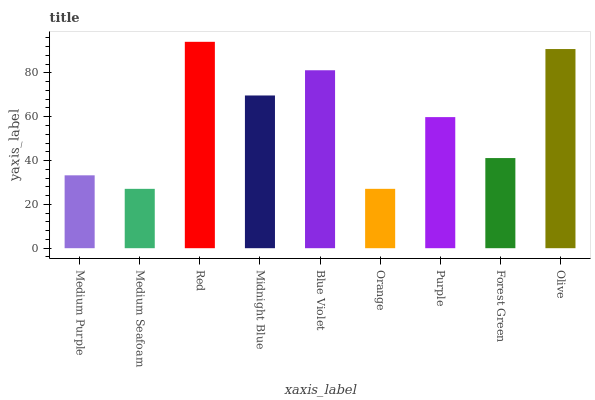Is Medium Seafoam the minimum?
Answer yes or no. Yes. Is Red the maximum?
Answer yes or no. Yes. Is Red the minimum?
Answer yes or no. No. Is Medium Seafoam the maximum?
Answer yes or no. No. Is Red greater than Medium Seafoam?
Answer yes or no. Yes. Is Medium Seafoam less than Red?
Answer yes or no. Yes. Is Medium Seafoam greater than Red?
Answer yes or no. No. Is Red less than Medium Seafoam?
Answer yes or no. No. Is Purple the high median?
Answer yes or no. Yes. Is Purple the low median?
Answer yes or no. Yes. Is Blue Violet the high median?
Answer yes or no. No. Is Orange the low median?
Answer yes or no. No. 